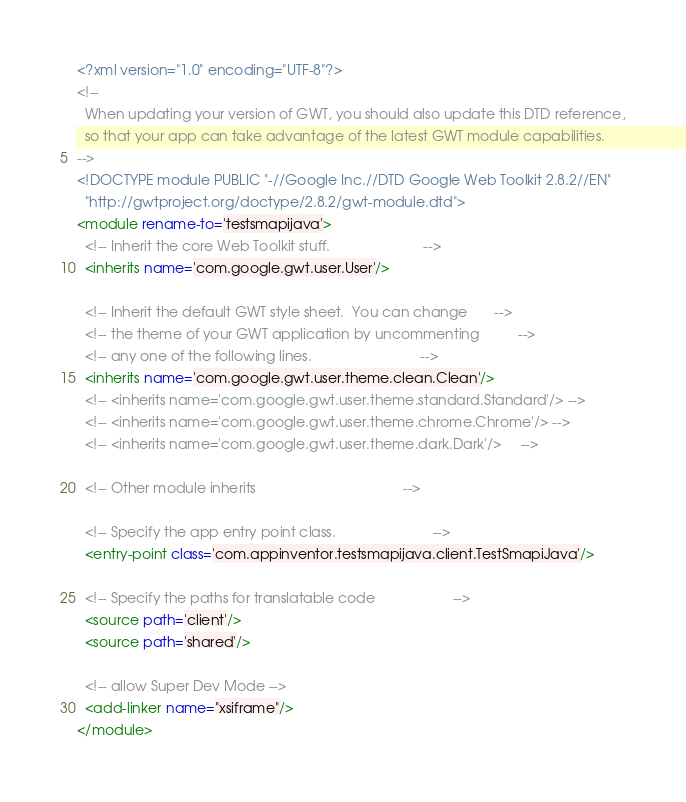<code> <loc_0><loc_0><loc_500><loc_500><_XML_><?xml version="1.0" encoding="UTF-8"?>
<!--
  When updating your version of GWT, you should also update this DTD reference,
  so that your app can take advantage of the latest GWT module capabilities.
-->
<!DOCTYPE module PUBLIC "-//Google Inc.//DTD Google Web Toolkit 2.8.2//EN"
  "http://gwtproject.org/doctype/2.8.2/gwt-module.dtd">
<module rename-to='testsmapijava'>
  <!-- Inherit the core Web Toolkit stuff.                        -->
  <inherits name='com.google.gwt.user.User'/>

  <!-- Inherit the default GWT style sheet.  You can change       -->
  <!-- the theme of your GWT application by uncommenting          -->
  <!-- any one of the following lines.                            -->
  <inherits name='com.google.gwt.user.theme.clean.Clean'/>
  <!-- <inherits name='com.google.gwt.user.theme.standard.Standard'/> -->
  <!-- <inherits name='com.google.gwt.user.theme.chrome.Chrome'/> -->
  <!-- <inherits name='com.google.gwt.user.theme.dark.Dark'/>     -->

  <!-- Other module inherits                                      -->

  <!-- Specify the app entry point class.                         -->
  <entry-point class='com.appinventor.testsmapijava.client.TestSmapiJava'/>

  <!-- Specify the paths for translatable code                    -->
  <source path='client'/>
  <source path='shared'/>

  <!-- allow Super Dev Mode -->
  <add-linker name="xsiframe"/>
</module>
</code> 